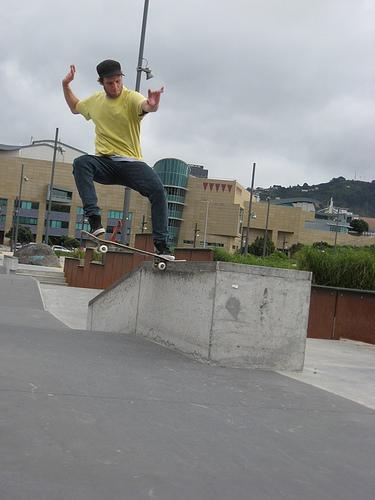What kind of trick is this skateboarder performing? jump 